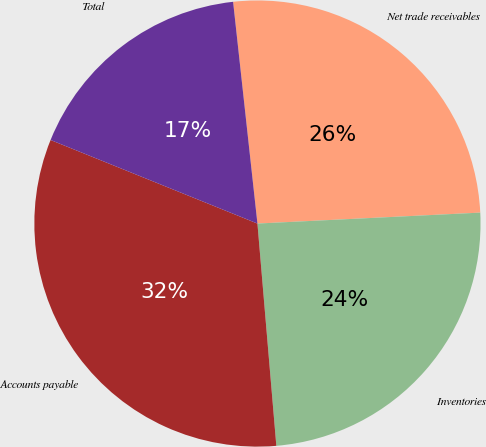Convert chart to OTSL. <chart><loc_0><loc_0><loc_500><loc_500><pie_chart><fcel>Net trade receivables<fcel>Inventories<fcel>Accounts payable<fcel>Total<nl><fcel>25.96%<fcel>24.43%<fcel>32.46%<fcel>17.15%<nl></chart> 